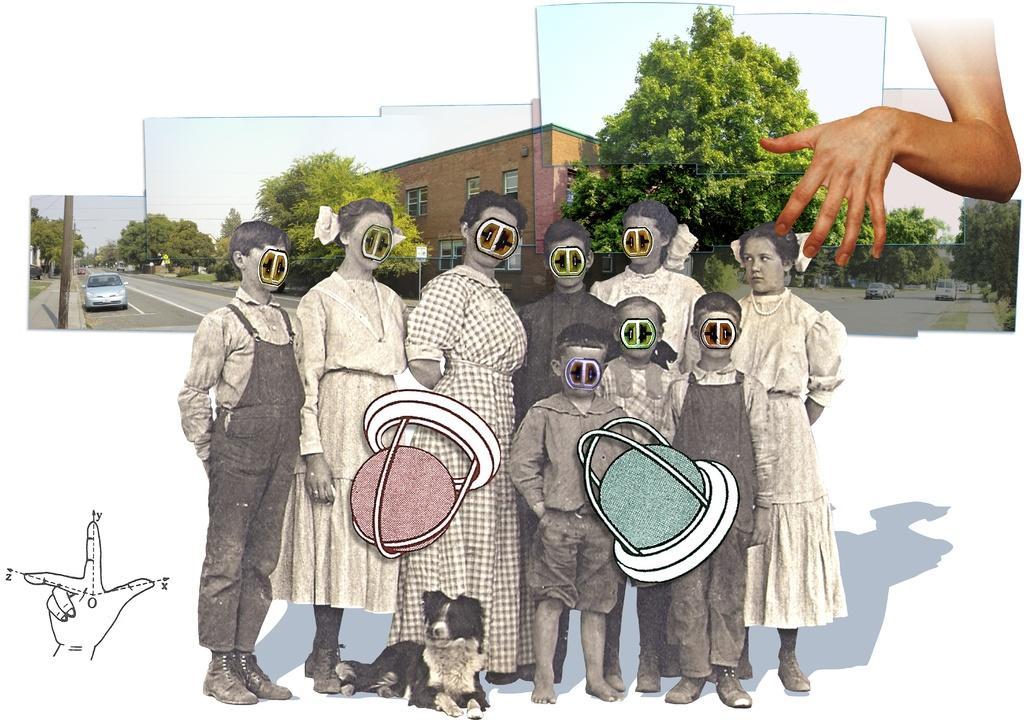In one or two sentences, can you explain what this image depicts? It is an edited image, there are some morphed images of few people and behind them there are different pictures of trees, houses and on the right side there is a hand. 